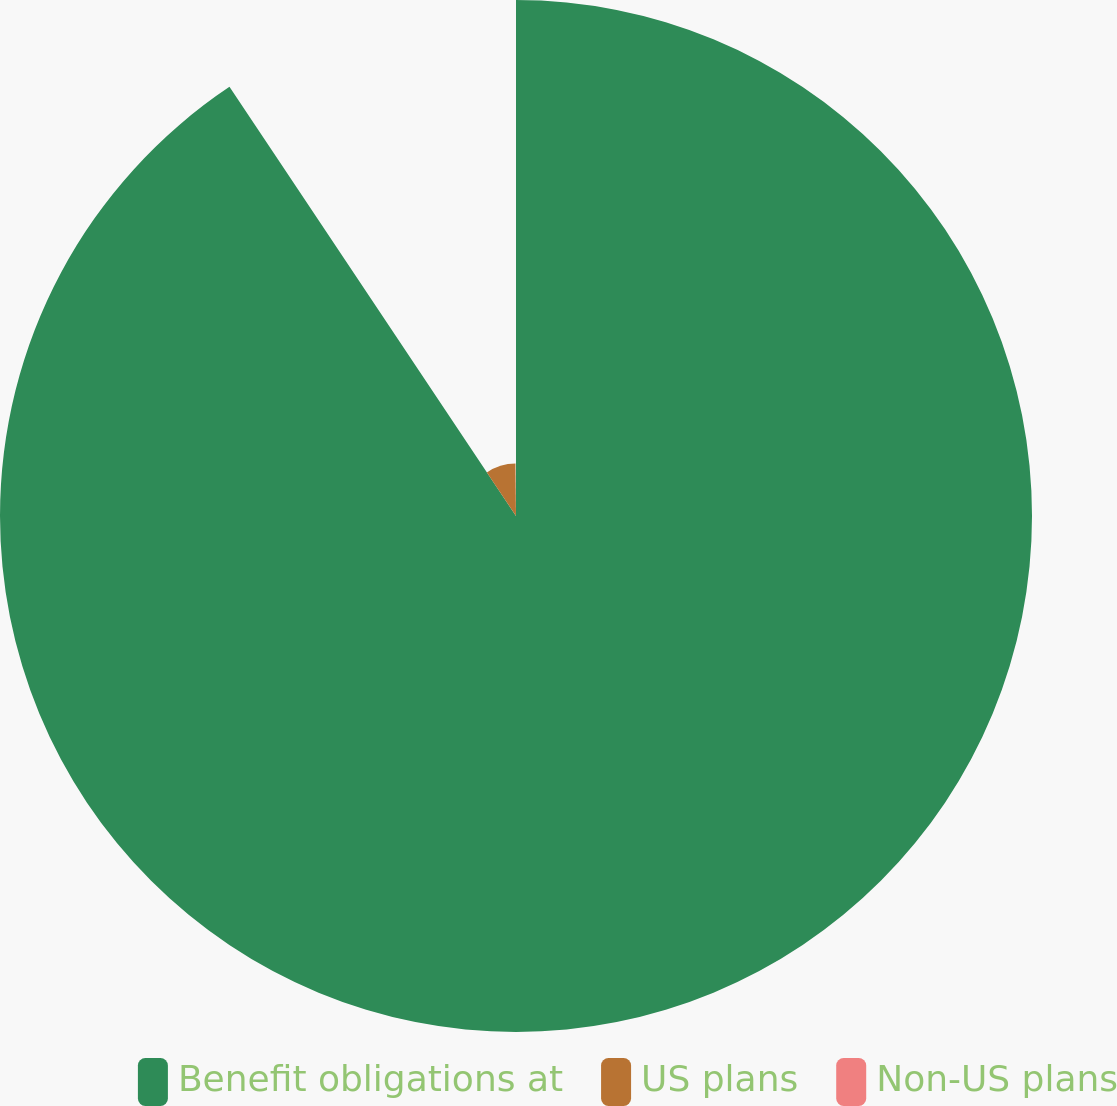Convert chart to OTSL. <chart><loc_0><loc_0><loc_500><loc_500><pie_chart><fcel>Benefit obligations at<fcel>US plans<fcel>Non-US plans<nl><fcel>90.63%<fcel>9.21%<fcel>0.16%<nl></chart> 